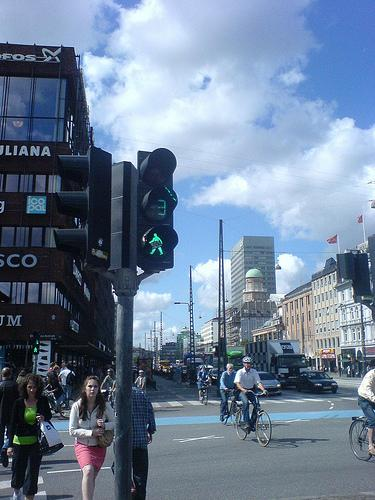Identify the color of the dome on a building in the image. The color of the dome on the building is light green. What is the sentiment and overall atmosphere of the image? The sentiment of the image is neutral and depicts daily life in an urban setting with people commuting and walking around. Describe the appearance of the man on the bicycle. The man on the bicycle has white hair and is wearing a helmet. How many people are crossing the street and what do they look like? Two people are crossing the street: a young woman in a white jacket and pink skirt, and a woman in black and green carrying a bag. Count and describe the types of flags in the image. There are two flags on white poles in the image. Assess the image quality based on object recognition and clarity of details. The image quality appears to be good with clear object recognition, as a variety of subjects have been identified with precise coordinates and descriptions. Analyze the interaction between the man on the bicycle and the women crossing the street. The man on the bicycle seems to be passing by while the women are crossing the street. They are maintaining a safe distance from each other. What type of truck is present in the image, and what are its colors? A black and white checkered semi truck is present in the image. What is the primary mode of transportation represented in the image? Bicycle is the primary mode of transportation represented. Notice how the clouds in the sky are forming the shape of a dragon. No, it's not mentioned in the image. 